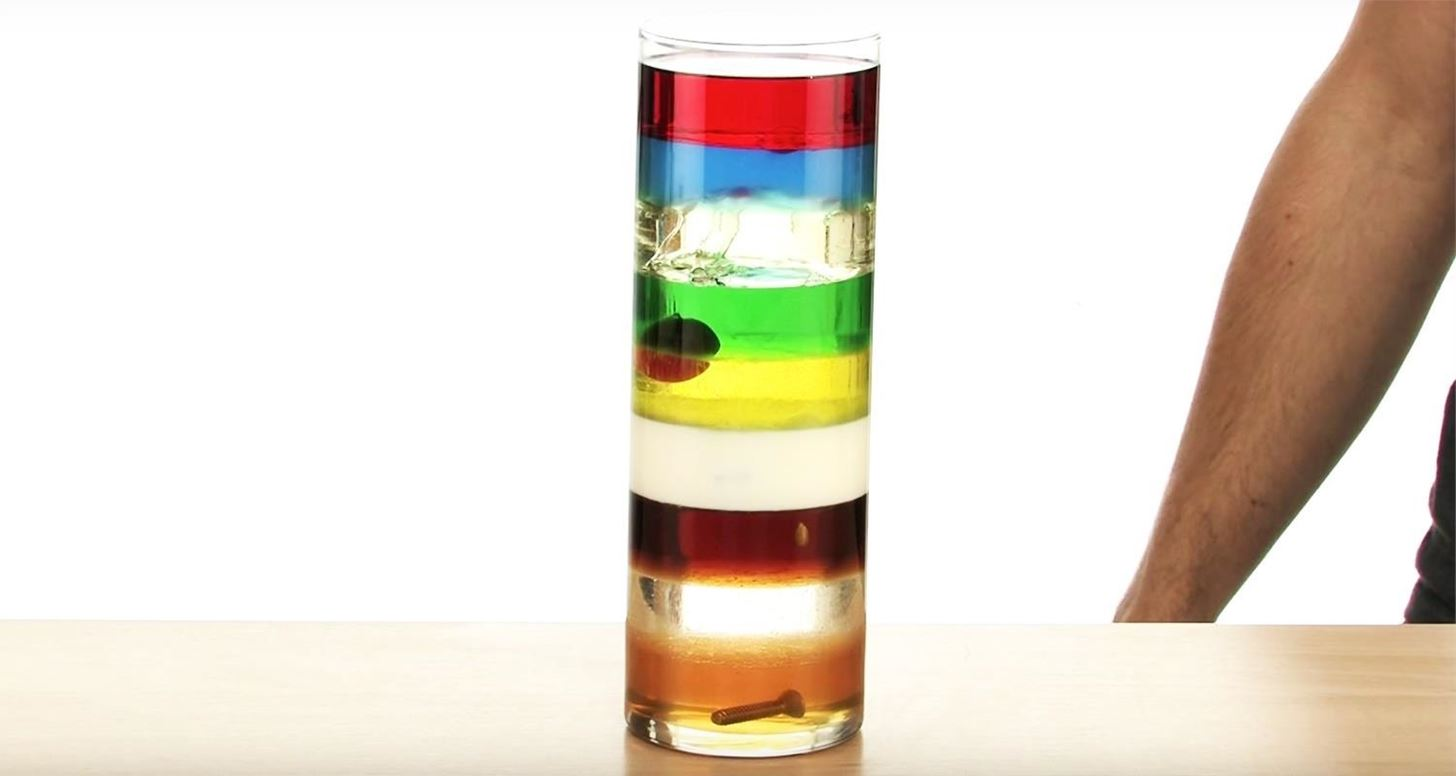Imagine this layered column in a zero-gravity environment. How would the appearance and behavior of the liquids change? In a zero-gravity environment, the distinct layers of liquids would not form as they do under the influence of gravity. Instead, the liquids would mix due to the lack of a gravitational force to facilitate density stratification. The mixture would form a somewhat homogenous blob, as there would be no force to pull the denser liquids down or allow the less dense liquids to rise. Surface tension would cause this blob to adopt a spherical shape or several spherical bubbles floating within the container. Can you explain a real-world application where understanding density stratification is crucial? Understanding density stratification is crucial in various fields, including environmental science, oceanography, and engineering. For example, in oceanography, it's important to study the density layers in oceans, which affects marine life, ocean currents, and climate. In engineering, particularly in petroleum extraction, understanding how different fluids settle in a well can improve extraction strategies. Additionally, in environmental science, stratification impacts the distribution of pollutants in water bodies, which is essential for managing and mitigating environmental damage. Understanding the principles of density requires recognizing how substances interact under gravitational forces and how they settle accordingly. 